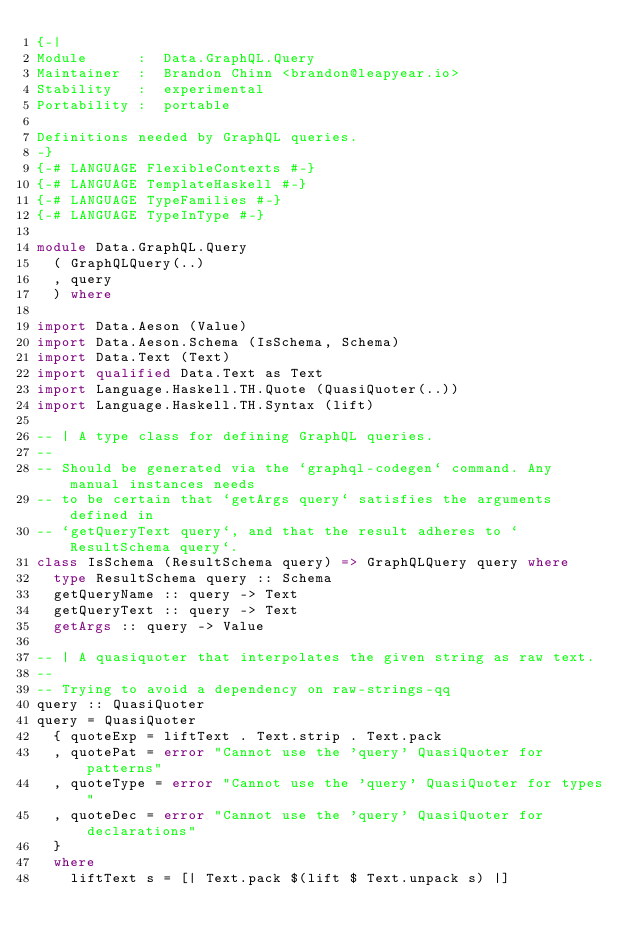Convert code to text. <code><loc_0><loc_0><loc_500><loc_500><_Haskell_>{-|
Module      :  Data.GraphQL.Query
Maintainer  :  Brandon Chinn <brandon@leapyear.io>
Stability   :  experimental
Portability :  portable

Definitions needed by GraphQL queries.
-}
{-# LANGUAGE FlexibleContexts #-}
{-# LANGUAGE TemplateHaskell #-}
{-# LANGUAGE TypeFamilies #-}
{-# LANGUAGE TypeInType #-}

module Data.GraphQL.Query
  ( GraphQLQuery(..)
  , query
  ) where

import Data.Aeson (Value)
import Data.Aeson.Schema (IsSchema, Schema)
import Data.Text (Text)
import qualified Data.Text as Text
import Language.Haskell.TH.Quote (QuasiQuoter(..))
import Language.Haskell.TH.Syntax (lift)

-- | A type class for defining GraphQL queries.
--
-- Should be generated via the `graphql-codegen` command. Any manual instances needs
-- to be certain that `getArgs query` satisfies the arguments defined in
-- `getQueryText query`, and that the result adheres to `ResultSchema query`.
class IsSchema (ResultSchema query) => GraphQLQuery query where
  type ResultSchema query :: Schema
  getQueryName :: query -> Text
  getQueryText :: query -> Text
  getArgs :: query -> Value

-- | A quasiquoter that interpolates the given string as raw text.
--
-- Trying to avoid a dependency on raw-strings-qq
query :: QuasiQuoter
query = QuasiQuoter
  { quoteExp = liftText . Text.strip . Text.pack
  , quotePat = error "Cannot use the 'query' QuasiQuoter for patterns"
  , quoteType = error "Cannot use the 'query' QuasiQuoter for types"
  , quoteDec = error "Cannot use the 'query' QuasiQuoter for declarations"
  }
  where
    liftText s = [| Text.pack $(lift $ Text.unpack s) |]
</code> 